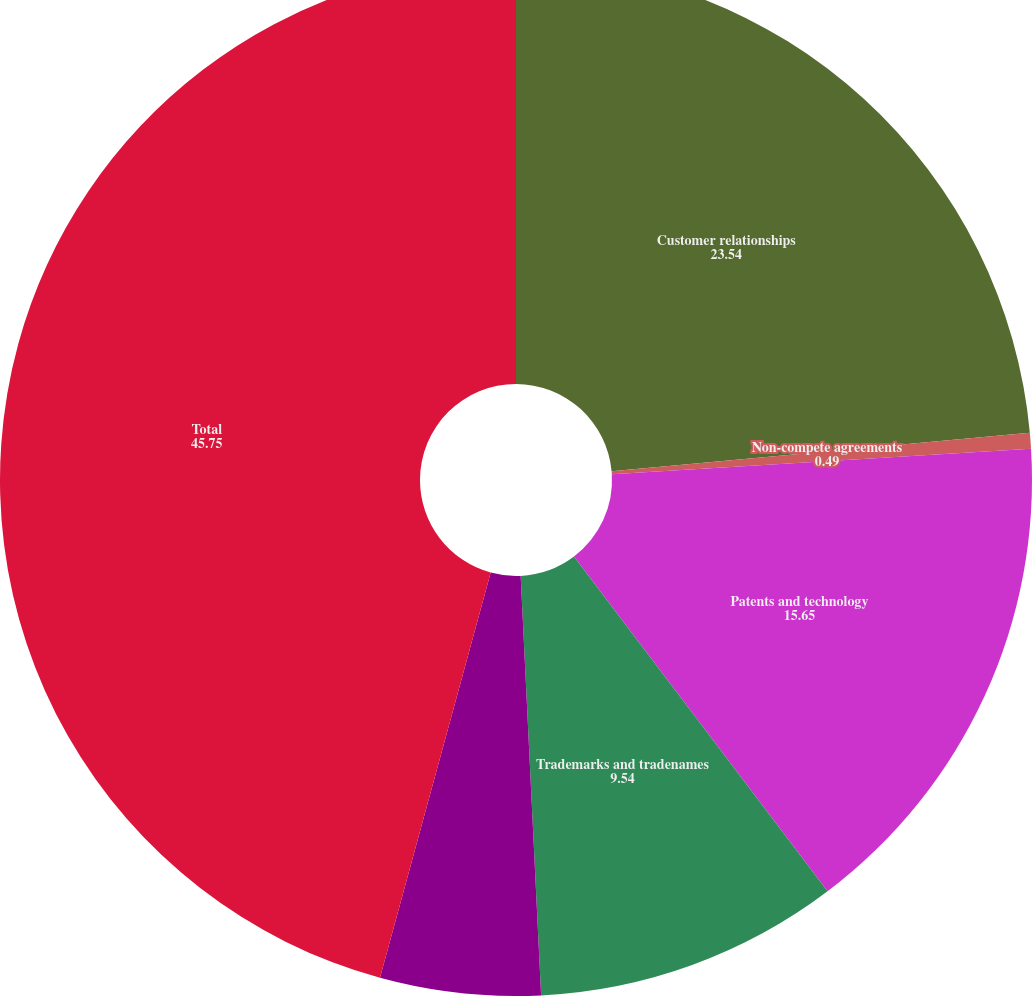Convert chart to OTSL. <chart><loc_0><loc_0><loc_500><loc_500><pie_chart><fcel>Customer relationships<fcel>Non-compete agreements<fcel>Patents and technology<fcel>Trademarks and tradenames<fcel>Supplier relationships<fcel>Total<nl><fcel>23.54%<fcel>0.49%<fcel>15.65%<fcel>9.54%<fcel>5.02%<fcel>45.75%<nl></chart> 